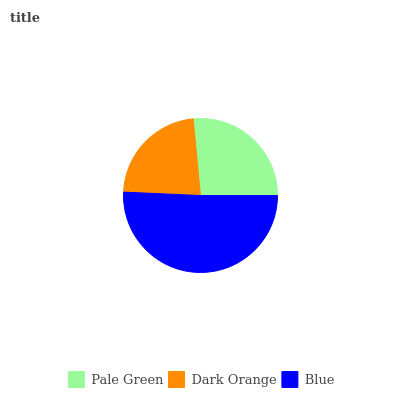Is Dark Orange the minimum?
Answer yes or no. Yes. Is Blue the maximum?
Answer yes or no. Yes. Is Blue the minimum?
Answer yes or no. No. Is Dark Orange the maximum?
Answer yes or no. No. Is Blue greater than Dark Orange?
Answer yes or no. Yes. Is Dark Orange less than Blue?
Answer yes or no. Yes. Is Dark Orange greater than Blue?
Answer yes or no. No. Is Blue less than Dark Orange?
Answer yes or no. No. Is Pale Green the high median?
Answer yes or no. Yes. Is Pale Green the low median?
Answer yes or no. Yes. Is Blue the high median?
Answer yes or no. No. Is Blue the low median?
Answer yes or no. No. 